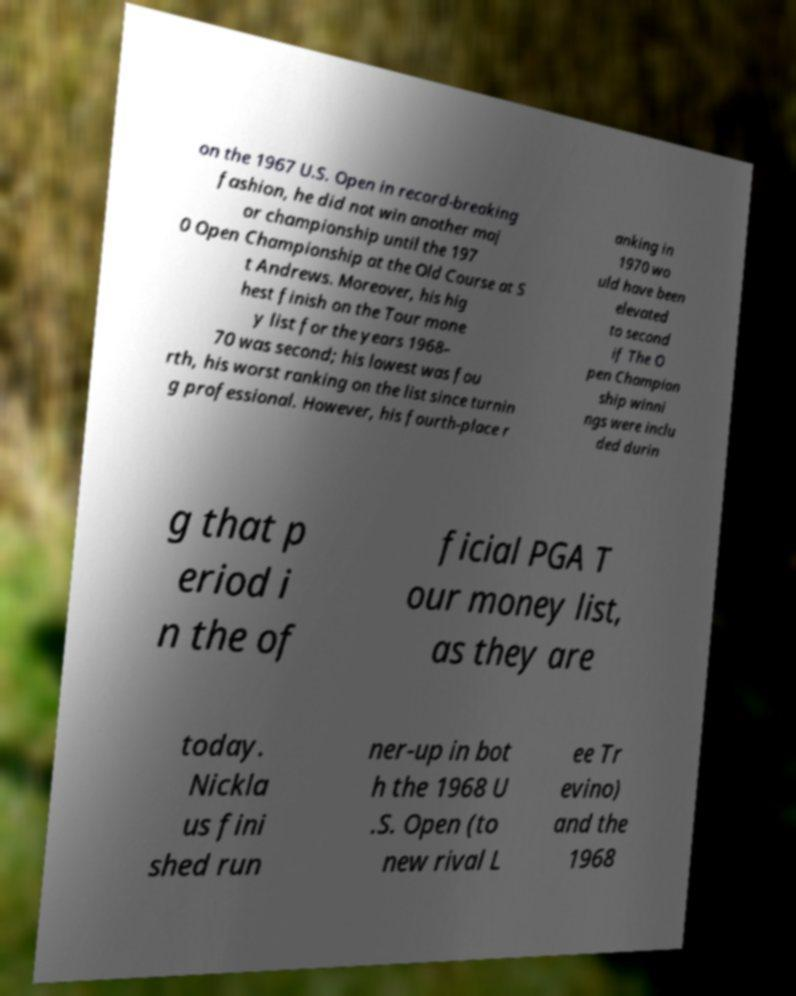I need the written content from this picture converted into text. Can you do that? on the 1967 U.S. Open in record-breaking fashion, he did not win another maj or championship until the 197 0 Open Championship at the Old Course at S t Andrews. Moreover, his hig hest finish on the Tour mone y list for the years 1968– 70 was second; his lowest was fou rth, his worst ranking on the list since turnin g professional. However, his fourth-place r anking in 1970 wo uld have been elevated to second if The O pen Champion ship winni ngs were inclu ded durin g that p eriod i n the of ficial PGA T our money list, as they are today. Nickla us fini shed run ner-up in bot h the 1968 U .S. Open (to new rival L ee Tr evino) and the 1968 